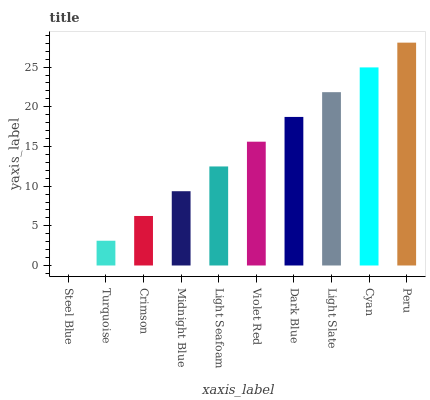Is Steel Blue the minimum?
Answer yes or no. Yes. Is Peru the maximum?
Answer yes or no. Yes. Is Turquoise the minimum?
Answer yes or no. No. Is Turquoise the maximum?
Answer yes or no. No. Is Turquoise greater than Steel Blue?
Answer yes or no. Yes. Is Steel Blue less than Turquoise?
Answer yes or no. Yes. Is Steel Blue greater than Turquoise?
Answer yes or no. No. Is Turquoise less than Steel Blue?
Answer yes or no. No. Is Violet Red the high median?
Answer yes or no. Yes. Is Light Seafoam the low median?
Answer yes or no. Yes. Is Light Slate the high median?
Answer yes or no. No. Is Cyan the low median?
Answer yes or no. No. 